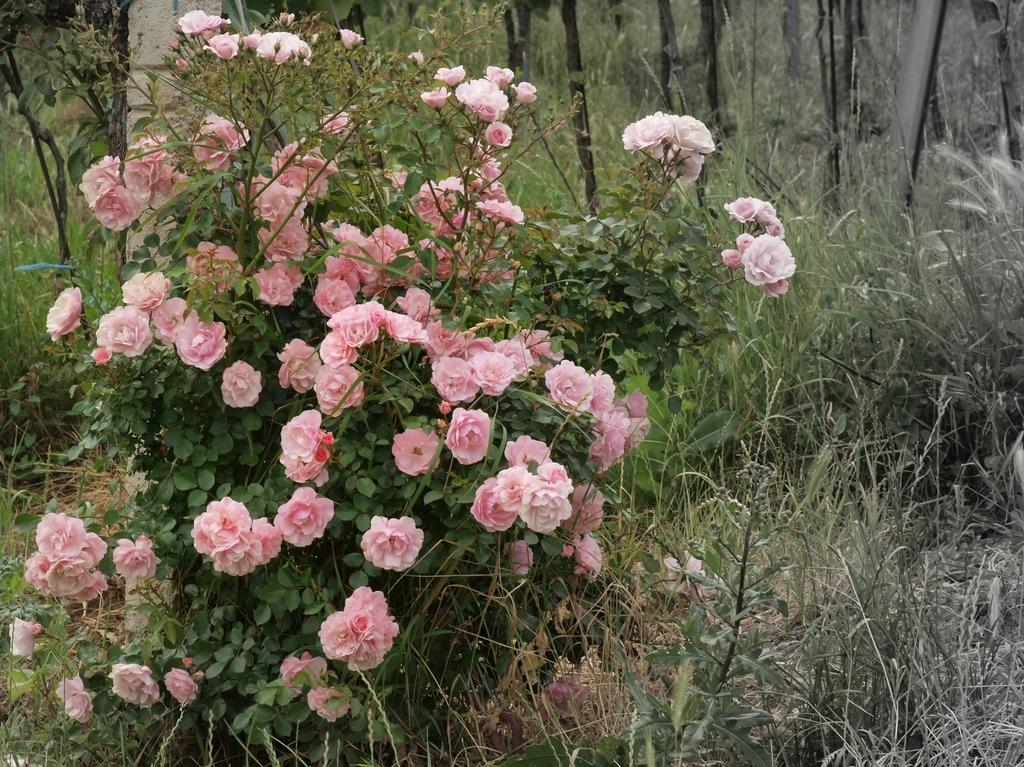What type of flowers can be seen in the image? There are pink flowers in the image. What other plant life is present in the image? There are plants in the image. What is the ground covered with in the image? There is grass in the image. What letters are being spelled out by the kitten in the image? There is no kitten present in the image, so no letters are being spelled out. 